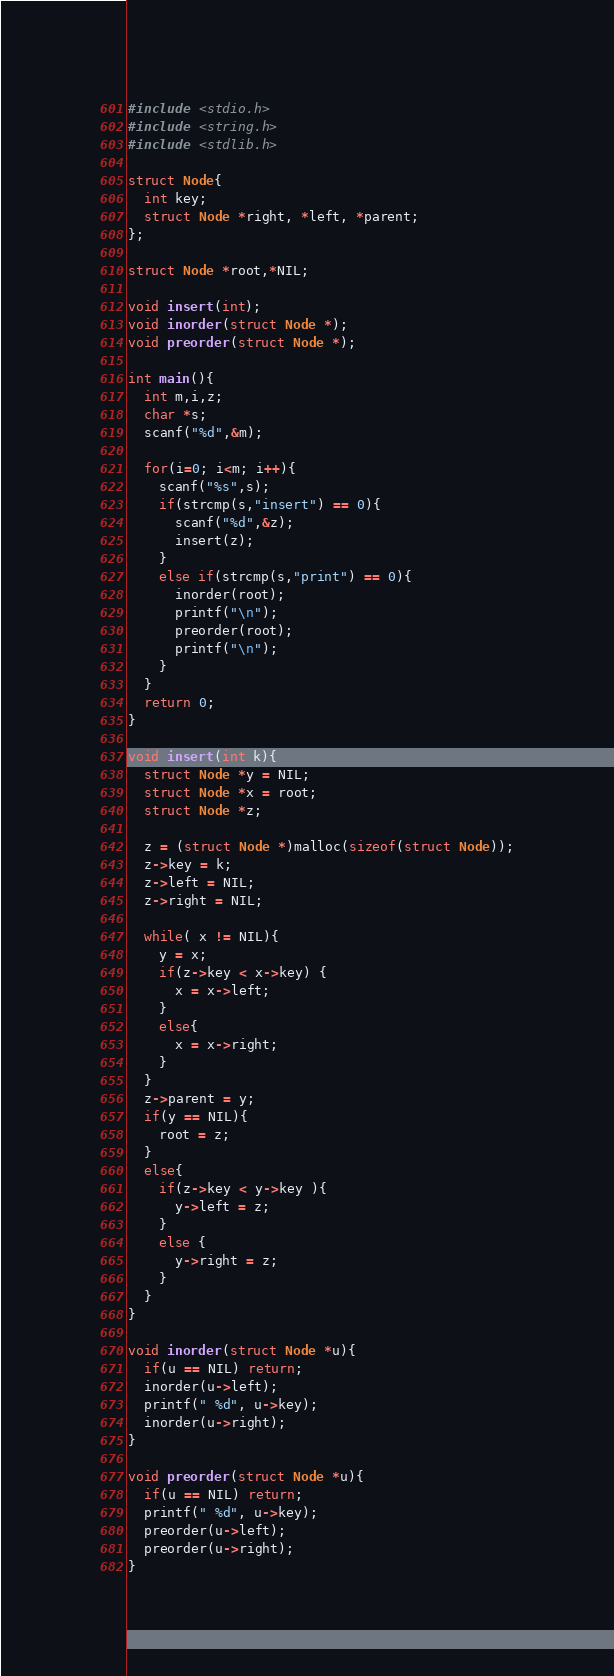Convert code to text. <code><loc_0><loc_0><loc_500><loc_500><_C_>#include <stdio.h>
#include <string.h>
#include <stdlib.h>

struct Node{
  int key;
  struct Node *right, *left, *parent;
};

struct Node *root,*NIL;

void insert(int);
void inorder(struct Node *);
void preorder(struct Node *);

int main(){
  int m,i,z;
  char *s;
  scanf("%d",&m);

  for(i=0; i<m; i++){
    scanf("%s",s);
    if(strcmp(s,"insert") == 0){
      scanf("%d",&z);
      insert(z);
    }
    else if(strcmp(s,"print") == 0){
      inorder(root);
      printf("\n");
      preorder(root);
      printf("\n");
    }
  }
  return 0;
}

void insert(int k){
  struct Node *y = NIL;
  struct Node *x = root;
  struct Node *z;

  z = (struct Node *)malloc(sizeof(struct Node));
  z->key = k;
  z->left = NIL;
  z->right = NIL;

  while( x != NIL){
    y = x;
    if(z->key < x->key) {
      x = x->left;
    }
    else{
      x = x->right;
    }
  }
  z->parent = y;
  if(y == NIL){
    root = z;
  }
  else{
    if(z->key < y->key ){
      y->left = z;
    }
    else {
      y->right = z;
    }
  }
}

void inorder(struct Node *u){
  if(u == NIL) return;
  inorder(u->left);
  printf(" %d", u->key);
  inorder(u->right);
}

void preorder(struct Node *u){
  if(u == NIL) return;
  printf(" %d", u->key);
  preorder(u->left);
  preorder(u->right);
}</code> 